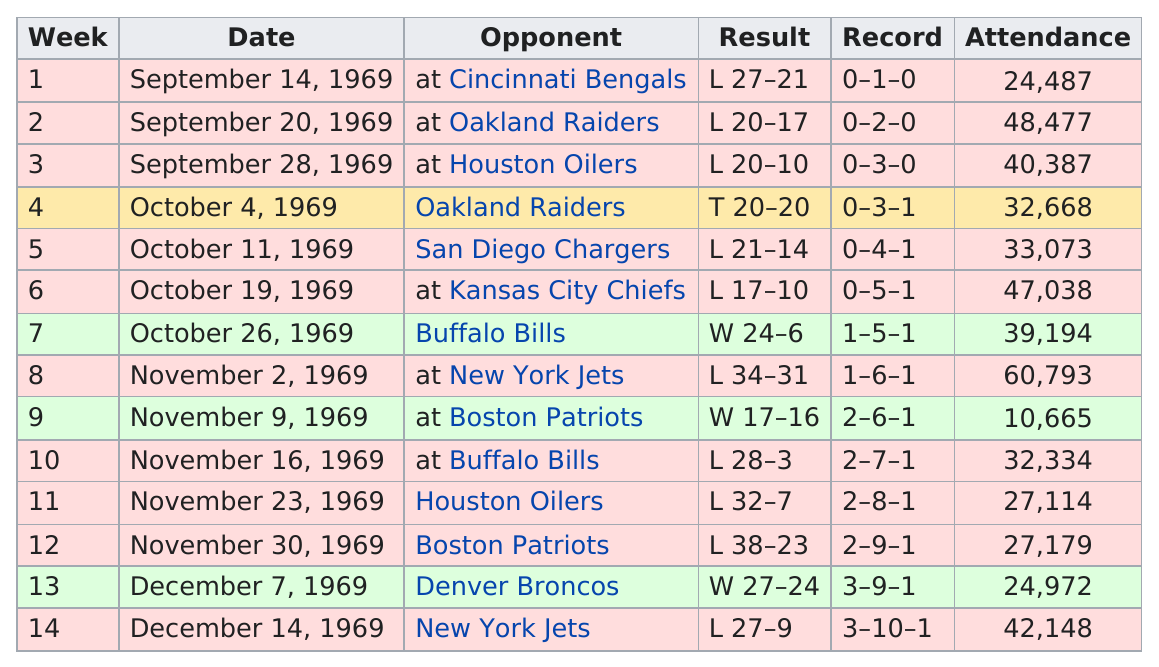List a handful of essential elements in this visual. There were four games played during the month of October in 1969. Which game had a bigger crowd, the one played in week 4 or the one played in week 9? The crowd was definitely bigger in week 4. On December 7, 1969, a total of 24,972 fans attended the game against the Broncos. The previous attendance for week 10 is 10,665. On November 2, prior to facing the New York Jets, the score of the game was W 24-6. 